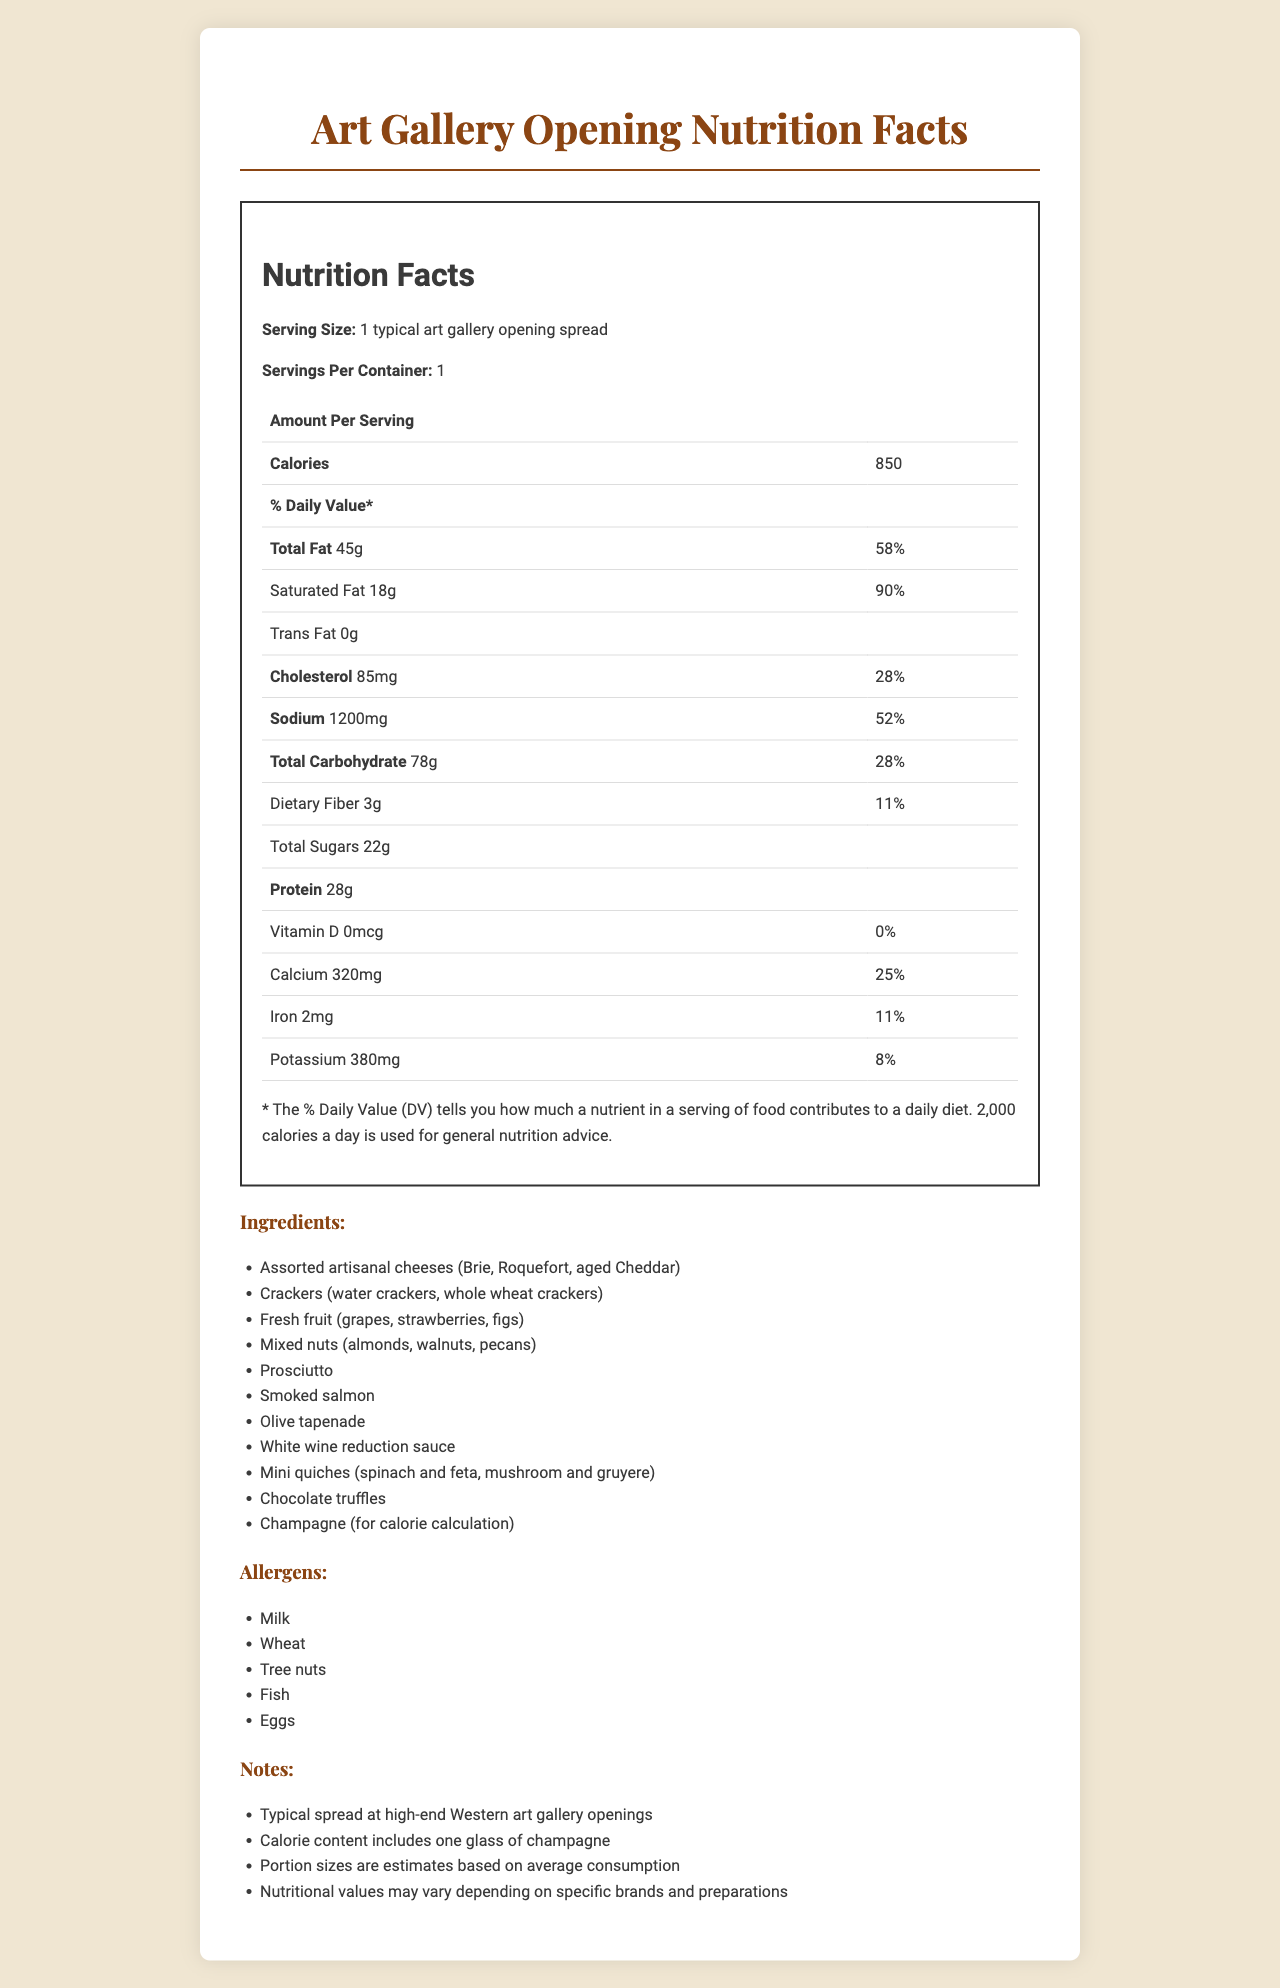what is the serving size specified in the nutrition facts? The serving size listed in the nutrition facts is "1 typical art gallery opening spread."
Answer: 1 typical art gallery opening spread how many calories are in a typical art gallery opening spread? The document states the calories amount per serving is 850.
Answer: 850 what is the total fat amount and its daily value percentage? The document specifies the total fat amount as 45g, which is 58% of the daily value.
Answer: 45g, 58% how much sodium does one serving contain? The sodium content for one serving is listed as 1200mg.
Answer: 1200mg which ingredients are included in the spread? The "Ingredients" section lists all these items.
Answer: Assorted artisanal cheeses, Crackers, Fresh fruit, Mixed nuts, Prosciutto, Smoked salmon, Olive tapenade, White wine reduction sauce, Mini quiches, Chocolate truffles, Champagne what is the amount of saturated fat per serving and its daily value percentage? The document indicates 18g of saturated fat per serving, which is 90% of the daily value.
Answer: 18g, 90% how much dietary fiber is in one serving? The document lists the dietary fiber content as 3g per serving.
Answer: 3g what are the allergens mentioned in the document? The allergens listed in the "Allergens" section are Milk, Wheat, Tree nuts, Fish, and Eggs.
Answer: Milk, Wheat, Tree nuts, Fish, Eggs what percentage of daily iron does one serving provide? The iron daily value percentage for one serving is listed as 11%.
Answer: 11% is there any vitamin D in a typical art gallery opening spread? The document states that the vitamin D amount is 0mcg and 0% of the daily value.
Answer: No which of the following items is NOT listed as an ingredient for the typical art gallery opening spread? A. Olive tapenade B. Dark chocolate C. Smoked salmon Dark chocolate is not among the listed ingredients, while Olive tapenade and Smoked salmon are.
Answer: B. Dark chocolate what is the carbohydrate content and its daily value percentage per serving? The document specifies the total carbohydrate content as 78g with a daily value of 28%.
Answer: 78g, 28% which item among the listed allergens is also a type of nuts? A. Milk B. Wheat C. Tree nuts Tree nuts is also a type of nuts and is listed among the allergens.
Answer: C. Tree nuts does the document include any information about vitamin C content? The document does not provide any information about vitamin C content.
Answer: No what is the main idea of the document? The document outlines the nutritional values, ingredients list, allergens, and relevant notes related to the common items served at a high-end Western art gallery opening.
Answer: The document provides nutritional information, ingredients, allergens, and additional notes for a typical art gallery opening spread. how many grams of protein are provided in one serving? The document lists the protein content as 28g per serving.
Answer: 28g what is the potassium content and its daily value percentage per serving? The potassium content per serving is 380mg, which is 8% of the daily value.
Answer: 380mg, 8% what effect does the inclusion of champagne have on the nutrition facts? One of the notes mentions that the calorie content includes one glass of champagne, indicating champagne's contribution to the total calories.
Answer: It contributes to the calorie content. does the document specify the brands of the ingredients used? The document does not specify the brands of the ingredients; it mentions that nutritional values may vary depending on specific brands and preparations.
Answer: No what is the calcium daily value percentage in one serving? The calcium daily value percentage per serving is listed as 25%.
Answer: 25% 